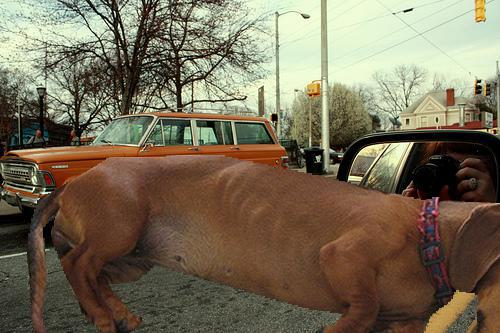Can you describe what the street looks like? The street appears to be typical of a residential area, with houses in the background, bare trees suggesting it might be fall or winter, and a clear sky. The scene captures a sense of everyday urban life. 